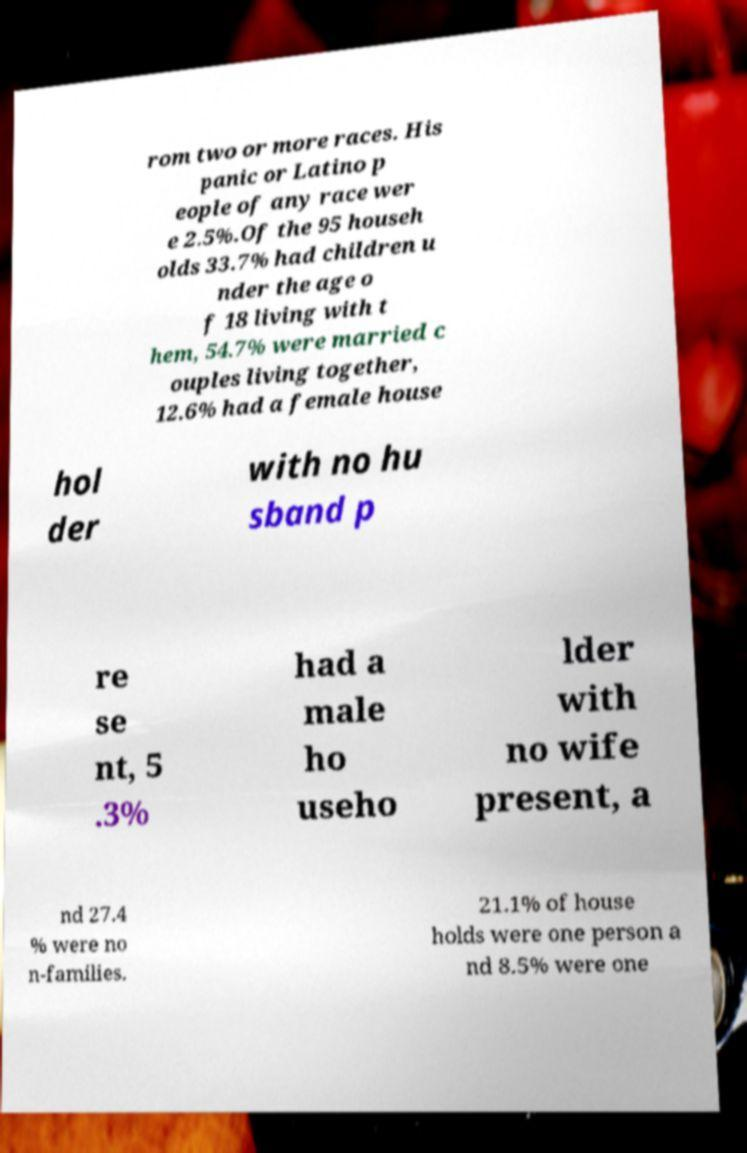For documentation purposes, I need the text within this image transcribed. Could you provide that? rom two or more races. His panic or Latino p eople of any race wer e 2.5%.Of the 95 househ olds 33.7% had children u nder the age o f 18 living with t hem, 54.7% were married c ouples living together, 12.6% had a female house hol der with no hu sband p re se nt, 5 .3% had a male ho useho lder with no wife present, a nd 27.4 % were no n-families. 21.1% of house holds were one person a nd 8.5% were one 